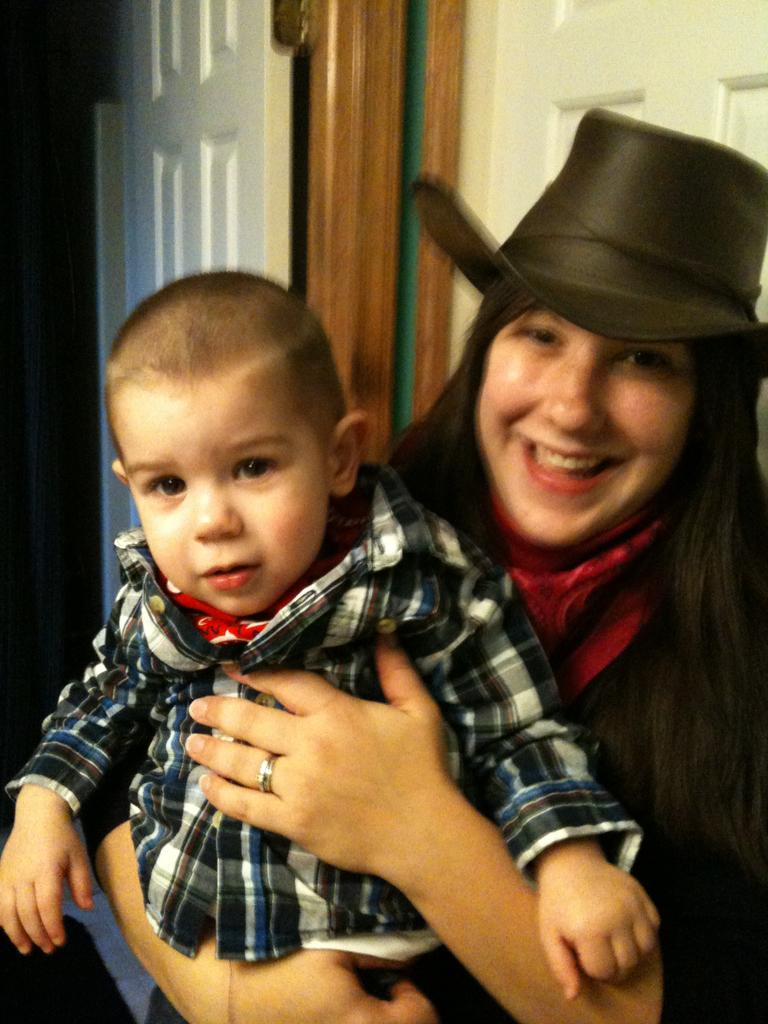Who is present in the image? There is a woman in the image. What is the woman wearing on her head? The woman is wearing a hat. What is the woman doing with her hands? The woman is holding a child with her hands. What expression does the woman have on her face? The woman is smiling. What can be seen in the background of the image? There are doors visible in the background of the image. What type of berry is the woman holding in her hand? There is no berry present in the image; the woman is holding a child with her hands. Can you see a pot in the image? There is no pot visible in the image. 